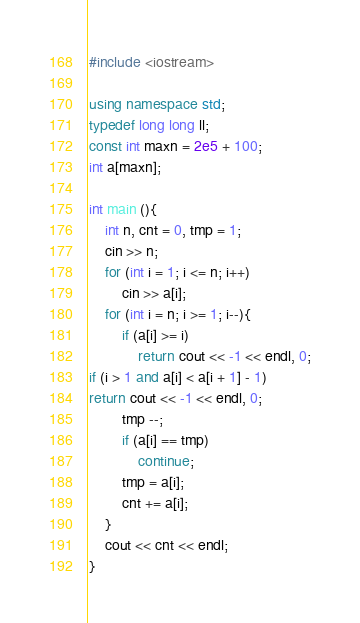<code> <loc_0><loc_0><loc_500><loc_500><_C++_>#include <iostream>
 
using namespace std;
typedef long long ll;
const int maxn = 2e5 + 100;
int a[maxn];
 
int main (){
    int n, cnt = 0, tmp = 1;
    cin >> n;
    for (int i = 1; i <= n; i++)
        cin >> a[i];
    for (int i = n; i >= 1; i--){
        if (a[i] >= i)
            return cout << -1 << endl, 0;
if (i > 1 and a[i] < a[i + 1] - 1)
return cout << -1 << endl, 0;
        tmp --;
        if (a[i] == tmp)
            continue;
        tmp = a[i];
        cnt += a[i];
    }
    cout << cnt << endl;
}</code> 